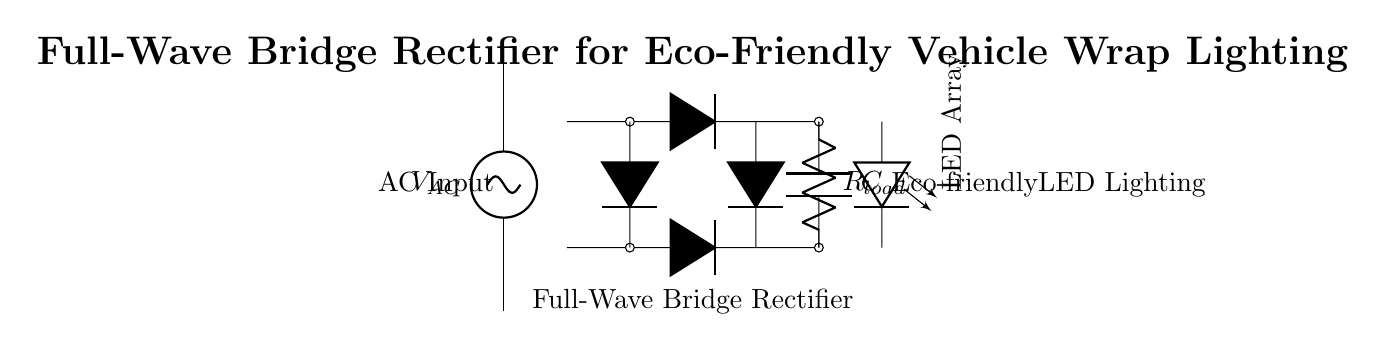What type of rectifier is shown in the diagram? The circuit diagram illustrates a full-wave bridge rectifier, which is identified by the arrangement of four diodes configured to convert both halves of an alternating current input into direct current.
Answer: full-wave bridge rectifier How many diodes are used in this rectifier? The diagram clearly shows four diodes connected in a bridge configuration, which is essential for enabling the full-wave rectification process by allowing current to flow through the load during both halves of the AC cycle.
Answer: four What is the purpose of the capacitor in this circuit? The capacitor in the circuit serves to smooth out the rectified DC voltage by charging during the peaks of the AC waveform and discharging when the voltage drops, ensuring a more stable output for the LED lighting system.
Answer: smoothing What load is connected to the rectifier? The circuit shows a resistor labeled as the load, which represents the LED array that receives the DC output from the rectifier to power the lighting in the vehicle wrap.
Answer: LED array What would happen if a single diode were used instead of the bridge rectifier? Using a single diode instead of the bridge rectifier would result in half-wave rectification, allowing current to pass only during one half of the AC cycle, which would produce a pulsating DC with lower average voltage and poor performance for the LED lighting.
Answer: half-wave rectification What effect does the rectifier have on the input AC voltage? The rectifier converts the alternating current input voltage into a direct current voltage, effectively changing the waveform from positive and negative cycles into a unidirectional flow of current suitable for powering devices like LEDs.
Answer: converts to DC voltage What is the role of the load resistor in the circuit? The load resistor represents the resistance of the LED array, limiting the amount of current flowing through the LEDs and ensuring they operate within their specified range for proper illumination in an eco-friendly manner.
Answer: current limiting 